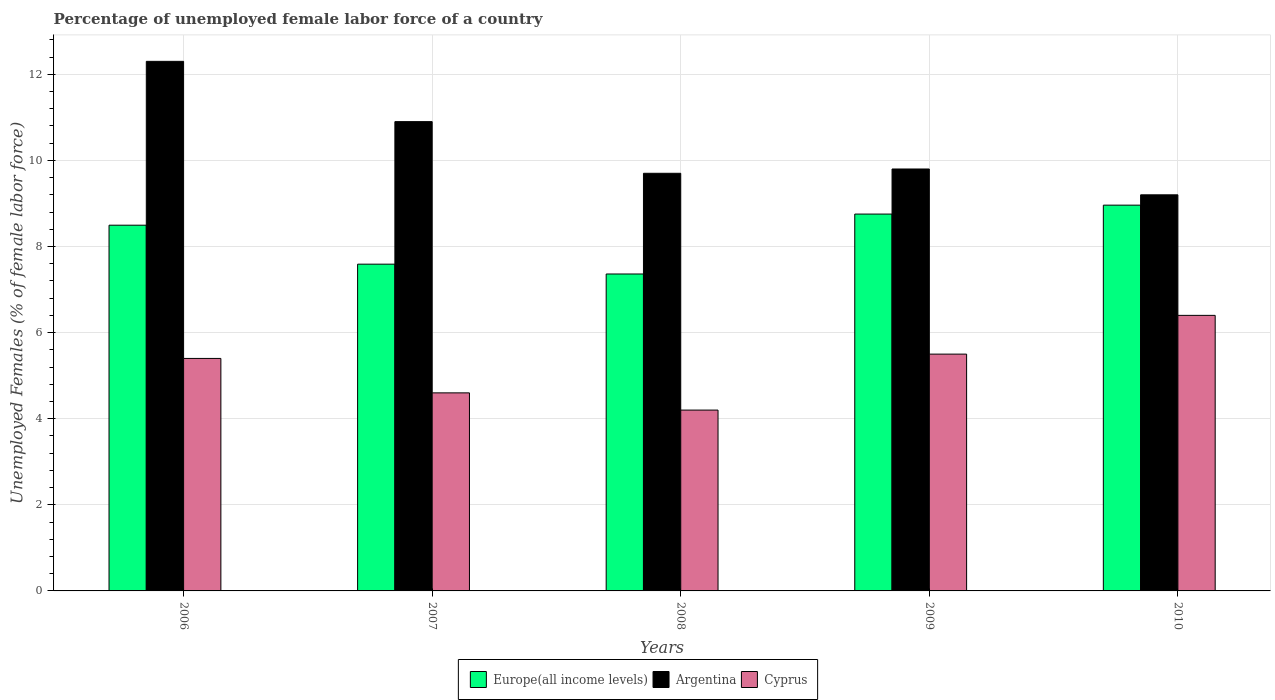How many different coloured bars are there?
Your response must be concise. 3. How many bars are there on the 4th tick from the left?
Your response must be concise. 3. How many bars are there on the 3rd tick from the right?
Provide a succinct answer. 3. In how many cases, is the number of bars for a given year not equal to the number of legend labels?
Your answer should be very brief. 0. What is the percentage of unemployed female labor force in Cyprus in 2007?
Offer a terse response. 4.6. Across all years, what is the maximum percentage of unemployed female labor force in Cyprus?
Keep it short and to the point. 6.4. Across all years, what is the minimum percentage of unemployed female labor force in Cyprus?
Your response must be concise. 4.2. What is the total percentage of unemployed female labor force in Cyprus in the graph?
Offer a terse response. 26.1. What is the difference between the percentage of unemployed female labor force in Argentina in 2006 and that in 2009?
Offer a terse response. 2.5. What is the difference between the percentage of unemployed female labor force in Europe(all income levels) in 2009 and the percentage of unemployed female labor force in Argentina in 2006?
Your response must be concise. -3.55. What is the average percentage of unemployed female labor force in Europe(all income levels) per year?
Give a very brief answer. 8.23. In the year 2010, what is the difference between the percentage of unemployed female labor force in Cyprus and percentage of unemployed female labor force in Europe(all income levels)?
Provide a succinct answer. -2.56. What is the ratio of the percentage of unemployed female labor force in Cyprus in 2009 to that in 2010?
Give a very brief answer. 0.86. Is the percentage of unemployed female labor force in Argentina in 2006 less than that in 2010?
Ensure brevity in your answer.  No. Is the difference between the percentage of unemployed female labor force in Cyprus in 2009 and 2010 greater than the difference between the percentage of unemployed female labor force in Europe(all income levels) in 2009 and 2010?
Your answer should be compact. No. What is the difference between the highest and the second highest percentage of unemployed female labor force in Cyprus?
Your answer should be compact. 0.9. What is the difference between the highest and the lowest percentage of unemployed female labor force in Europe(all income levels)?
Provide a short and direct response. 1.6. Is the sum of the percentage of unemployed female labor force in Europe(all income levels) in 2008 and 2010 greater than the maximum percentage of unemployed female labor force in Argentina across all years?
Keep it short and to the point. Yes. What does the 1st bar from the left in 2009 represents?
Give a very brief answer. Europe(all income levels). What does the 1st bar from the right in 2007 represents?
Provide a short and direct response. Cyprus. Is it the case that in every year, the sum of the percentage of unemployed female labor force in Cyprus and percentage of unemployed female labor force in Argentina is greater than the percentage of unemployed female labor force in Europe(all income levels)?
Make the answer very short. Yes. How many bars are there?
Make the answer very short. 15. How many years are there in the graph?
Provide a succinct answer. 5. Does the graph contain any zero values?
Give a very brief answer. No. Does the graph contain grids?
Provide a short and direct response. Yes. Where does the legend appear in the graph?
Provide a short and direct response. Bottom center. How many legend labels are there?
Provide a short and direct response. 3. How are the legend labels stacked?
Offer a very short reply. Horizontal. What is the title of the graph?
Offer a terse response. Percentage of unemployed female labor force of a country. What is the label or title of the Y-axis?
Make the answer very short. Unemployed Females (% of female labor force). What is the Unemployed Females (% of female labor force) of Europe(all income levels) in 2006?
Offer a terse response. 8.49. What is the Unemployed Females (% of female labor force) in Argentina in 2006?
Offer a terse response. 12.3. What is the Unemployed Females (% of female labor force) in Cyprus in 2006?
Provide a short and direct response. 5.4. What is the Unemployed Females (% of female labor force) of Europe(all income levels) in 2007?
Your answer should be compact. 7.59. What is the Unemployed Females (% of female labor force) in Argentina in 2007?
Provide a short and direct response. 10.9. What is the Unemployed Females (% of female labor force) in Cyprus in 2007?
Give a very brief answer. 4.6. What is the Unemployed Females (% of female labor force) of Europe(all income levels) in 2008?
Provide a short and direct response. 7.36. What is the Unemployed Females (% of female labor force) in Argentina in 2008?
Ensure brevity in your answer.  9.7. What is the Unemployed Females (% of female labor force) in Cyprus in 2008?
Keep it short and to the point. 4.2. What is the Unemployed Females (% of female labor force) of Europe(all income levels) in 2009?
Offer a terse response. 8.75. What is the Unemployed Females (% of female labor force) in Argentina in 2009?
Your answer should be compact. 9.8. What is the Unemployed Females (% of female labor force) in Europe(all income levels) in 2010?
Provide a short and direct response. 8.96. What is the Unemployed Females (% of female labor force) of Argentina in 2010?
Your answer should be compact. 9.2. What is the Unemployed Females (% of female labor force) in Cyprus in 2010?
Your response must be concise. 6.4. Across all years, what is the maximum Unemployed Females (% of female labor force) in Europe(all income levels)?
Provide a short and direct response. 8.96. Across all years, what is the maximum Unemployed Females (% of female labor force) in Argentina?
Give a very brief answer. 12.3. Across all years, what is the maximum Unemployed Females (% of female labor force) of Cyprus?
Provide a succinct answer. 6.4. Across all years, what is the minimum Unemployed Females (% of female labor force) of Europe(all income levels)?
Provide a short and direct response. 7.36. Across all years, what is the minimum Unemployed Females (% of female labor force) in Argentina?
Make the answer very short. 9.2. Across all years, what is the minimum Unemployed Females (% of female labor force) of Cyprus?
Your answer should be very brief. 4.2. What is the total Unemployed Females (% of female labor force) in Europe(all income levels) in the graph?
Offer a very short reply. 41.16. What is the total Unemployed Females (% of female labor force) of Argentina in the graph?
Provide a short and direct response. 51.9. What is the total Unemployed Females (% of female labor force) in Cyprus in the graph?
Offer a very short reply. 26.1. What is the difference between the Unemployed Females (% of female labor force) of Europe(all income levels) in 2006 and that in 2007?
Offer a terse response. 0.91. What is the difference between the Unemployed Females (% of female labor force) of Argentina in 2006 and that in 2007?
Your answer should be compact. 1.4. What is the difference between the Unemployed Females (% of female labor force) in Europe(all income levels) in 2006 and that in 2008?
Provide a succinct answer. 1.13. What is the difference between the Unemployed Females (% of female labor force) in Argentina in 2006 and that in 2008?
Ensure brevity in your answer.  2.6. What is the difference between the Unemployed Females (% of female labor force) in Cyprus in 2006 and that in 2008?
Your answer should be compact. 1.2. What is the difference between the Unemployed Females (% of female labor force) of Europe(all income levels) in 2006 and that in 2009?
Your answer should be very brief. -0.26. What is the difference between the Unemployed Females (% of female labor force) in Argentina in 2006 and that in 2009?
Make the answer very short. 2.5. What is the difference between the Unemployed Females (% of female labor force) in Cyprus in 2006 and that in 2009?
Give a very brief answer. -0.1. What is the difference between the Unemployed Females (% of female labor force) of Europe(all income levels) in 2006 and that in 2010?
Keep it short and to the point. -0.47. What is the difference between the Unemployed Females (% of female labor force) in Argentina in 2006 and that in 2010?
Keep it short and to the point. 3.1. What is the difference between the Unemployed Females (% of female labor force) of Cyprus in 2006 and that in 2010?
Your answer should be compact. -1. What is the difference between the Unemployed Females (% of female labor force) of Europe(all income levels) in 2007 and that in 2008?
Your answer should be compact. 0.23. What is the difference between the Unemployed Females (% of female labor force) of Europe(all income levels) in 2007 and that in 2009?
Provide a short and direct response. -1.16. What is the difference between the Unemployed Females (% of female labor force) in Cyprus in 2007 and that in 2009?
Provide a short and direct response. -0.9. What is the difference between the Unemployed Females (% of female labor force) of Europe(all income levels) in 2007 and that in 2010?
Your response must be concise. -1.37. What is the difference between the Unemployed Females (% of female labor force) of Cyprus in 2007 and that in 2010?
Your response must be concise. -1.8. What is the difference between the Unemployed Females (% of female labor force) of Europe(all income levels) in 2008 and that in 2009?
Make the answer very short. -1.39. What is the difference between the Unemployed Females (% of female labor force) of Cyprus in 2008 and that in 2009?
Provide a short and direct response. -1.3. What is the difference between the Unemployed Females (% of female labor force) of Europe(all income levels) in 2008 and that in 2010?
Make the answer very short. -1.6. What is the difference between the Unemployed Females (% of female labor force) in Cyprus in 2008 and that in 2010?
Keep it short and to the point. -2.2. What is the difference between the Unemployed Females (% of female labor force) in Europe(all income levels) in 2009 and that in 2010?
Make the answer very short. -0.21. What is the difference between the Unemployed Females (% of female labor force) in Cyprus in 2009 and that in 2010?
Offer a terse response. -0.9. What is the difference between the Unemployed Females (% of female labor force) of Europe(all income levels) in 2006 and the Unemployed Females (% of female labor force) of Argentina in 2007?
Ensure brevity in your answer.  -2.41. What is the difference between the Unemployed Females (% of female labor force) in Europe(all income levels) in 2006 and the Unemployed Females (% of female labor force) in Cyprus in 2007?
Your response must be concise. 3.89. What is the difference between the Unemployed Females (% of female labor force) of Europe(all income levels) in 2006 and the Unemployed Females (% of female labor force) of Argentina in 2008?
Ensure brevity in your answer.  -1.21. What is the difference between the Unemployed Females (% of female labor force) of Europe(all income levels) in 2006 and the Unemployed Females (% of female labor force) of Cyprus in 2008?
Give a very brief answer. 4.29. What is the difference between the Unemployed Females (% of female labor force) in Argentina in 2006 and the Unemployed Females (% of female labor force) in Cyprus in 2008?
Ensure brevity in your answer.  8.1. What is the difference between the Unemployed Females (% of female labor force) of Europe(all income levels) in 2006 and the Unemployed Females (% of female labor force) of Argentina in 2009?
Your answer should be very brief. -1.31. What is the difference between the Unemployed Females (% of female labor force) of Europe(all income levels) in 2006 and the Unemployed Females (% of female labor force) of Cyprus in 2009?
Your answer should be compact. 2.99. What is the difference between the Unemployed Females (% of female labor force) in Argentina in 2006 and the Unemployed Females (% of female labor force) in Cyprus in 2009?
Ensure brevity in your answer.  6.8. What is the difference between the Unemployed Females (% of female labor force) of Europe(all income levels) in 2006 and the Unemployed Females (% of female labor force) of Argentina in 2010?
Ensure brevity in your answer.  -0.71. What is the difference between the Unemployed Females (% of female labor force) of Europe(all income levels) in 2006 and the Unemployed Females (% of female labor force) of Cyprus in 2010?
Offer a terse response. 2.09. What is the difference between the Unemployed Females (% of female labor force) of Argentina in 2006 and the Unemployed Females (% of female labor force) of Cyprus in 2010?
Provide a succinct answer. 5.9. What is the difference between the Unemployed Females (% of female labor force) of Europe(all income levels) in 2007 and the Unemployed Females (% of female labor force) of Argentina in 2008?
Provide a succinct answer. -2.11. What is the difference between the Unemployed Females (% of female labor force) in Europe(all income levels) in 2007 and the Unemployed Females (% of female labor force) in Cyprus in 2008?
Your response must be concise. 3.39. What is the difference between the Unemployed Females (% of female labor force) in Argentina in 2007 and the Unemployed Females (% of female labor force) in Cyprus in 2008?
Offer a terse response. 6.7. What is the difference between the Unemployed Females (% of female labor force) of Europe(all income levels) in 2007 and the Unemployed Females (% of female labor force) of Argentina in 2009?
Your answer should be compact. -2.21. What is the difference between the Unemployed Females (% of female labor force) of Europe(all income levels) in 2007 and the Unemployed Females (% of female labor force) of Cyprus in 2009?
Your answer should be compact. 2.09. What is the difference between the Unemployed Females (% of female labor force) in Europe(all income levels) in 2007 and the Unemployed Females (% of female labor force) in Argentina in 2010?
Give a very brief answer. -1.61. What is the difference between the Unemployed Females (% of female labor force) in Europe(all income levels) in 2007 and the Unemployed Females (% of female labor force) in Cyprus in 2010?
Your answer should be compact. 1.19. What is the difference between the Unemployed Females (% of female labor force) of Europe(all income levels) in 2008 and the Unemployed Females (% of female labor force) of Argentina in 2009?
Ensure brevity in your answer.  -2.44. What is the difference between the Unemployed Females (% of female labor force) in Europe(all income levels) in 2008 and the Unemployed Females (% of female labor force) in Cyprus in 2009?
Offer a terse response. 1.86. What is the difference between the Unemployed Females (% of female labor force) of Europe(all income levels) in 2008 and the Unemployed Females (% of female labor force) of Argentina in 2010?
Make the answer very short. -1.84. What is the difference between the Unemployed Females (% of female labor force) in Europe(all income levels) in 2008 and the Unemployed Females (% of female labor force) in Cyprus in 2010?
Your answer should be compact. 0.96. What is the difference between the Unemployed Females (% of female labor force) in Argentina in 2008 and the Unemployed Females (% of female labor force) in Cyprus in 2010?
Offer a terse response. 3.3. What is the difference between the Unemployed Females (% of female labor force) of Europe(all income levels) in 2009 and the Unemployed Females (% of female labor force) of Argentina in 2010?
Provide a succinct answer. -0.45. What is the difference between the Unemployed Females (% of female labor force) in Europe(all income levels) in 2009 and the Unemployed Females (% of female labor force) in Cyprus in 2010?
Give a very brief answer. 2.35. What is the average Unemployed Females (% of female labor force) in Europe(all income levels) per year?
Offer a terse response. 8.23. What is the average Unemployed Females (% of female labor force) in Argentina per year?
Ensure brevity in your answer.  10.38. What is the average Unemployed Females (% of female labor force) of Cyprus per year?
Keep it short and to the point. 5.22. In the year 2006, what is the difference between the Unemployed Females (% of female labor force) in Europe(all income levels) and Unemployed Females (% of female labor force) in Argentina?
Your answer should be compact. -3.81. In the year 2006, what is the difference between the Unemployed Females (% of female labor force) of Europe(all income levels) and Unemployed Females (% of female labor force) of Cyprus?
Ensure brevity in your answer.  3.09. In the year 2006, what is the difference between the Unemployed Females (% of female labor force) in Argentina and Unemployed Females (% of female labor force) in Cyprus?
Give a very brief answer. 6.9. In the year 2007, what is the difference between the Unemployed Females (% of female labor force) in Europe(all income levels) and Unemployed Females (% of female labor force) in Argentina?
Make the answer very short. -3.31. In the year 2007, what is the difference between the Unemployed Females (% of female labor force) in Europe(all income levels) and Unemployed Females (% of female labor force) in Cyprus?
Ensure brevity in your answer.  2.99. In the year 2008, what is the difference between the Unemployed Females (% of female labor force) of Europe(all income levels) and Unemployed Females (% of female labor force) of Argentina?
Keep it short and to the point. -2.34. In the year 2008, what is the difference between the Unemployed Females (% of female labor force) in Europe(all income levels) and Unemployed Females (% of female labor force) in Cyprus?
Provide a succinct answer. 3.16. In the year 2009, what is the difference between the Unemployed Females (% of female labor force) in Europe(all income levels) and Unemployed Females (% of female labor force) in Argentina?
Your response must be concise. -1.05. In the year 2009, what is the difference between the Unemployed Females (% of female labor force) in Europe(all income levels) and Unemployed Females (% of female labor force) in Cyprus?
Ensure brevity in your answer.  3.25. In the year 2010, what is the difference between the Unemployed Females (% of female labor force) of Europe(all income levels) and Unemployed Females (% of female labor force) of Argentina?
Offer a terse response. -0.24. In the year 2010, what is the difference between the Unemployed Females (% of female labor force) in Europe(all income levels) and Unemployed Females (% of female labor force) in Cyprus?
Provide a short and direct response. 2.56. In the year 2010, what is the difference between the Unemployed Females (% of female labor force) in Argentina and Unemployed Females (% of female labor force) in Cyprus?
Keep it short and to the point. 2.8. What is the ratio of the Unemployed Females (% of female labor force) of Europe(all income levels) in 2006 to that in 2007?
Offer a very short reply. 1.12. What is the ratio of the Unemployed Females (% of female labor force) in Argentina in 2006 to that in 2007?
Keep it short and to the point. 1.13. What is the ratio of the Unemployed Females (% of female labor force) of Cyprus in 2006 to that in 2007?
Provide a short and direct response. 1.17. What is the ratio of the Unemployed Females (% of female labor force) in Europe(all income levels) in 2006 to that in 2008?
Provide a short and direct response. 1.15. What is the ratio of the Unemployed Females (% of female labor force) in Argentina in 2006 to that in 2008?
Keep it short and to the point. 1.27. What is the ratio of the Unemployed Females (% of female labor force) in Europe(all income levels) in 2006 to that in 2009?
Make the answer very short. 0.97. What is the ratio of the Unemployed Females (% of female labor force) of Argentina in 2006 to that in 2009?
Offer a very short reply. 1.26. What is the ratio of the Unemployed Females (% of female labor force) of Cyprus in 2006 to that in 2009?
Your answer should be very brief. 0.98. What is the ratio of the Unemployed Females (% of female labor force) in Europe(all income levels) in 2006 to that in 2010?
Provide a succinct answer. 0.95. What is the ratio of the Unemployed Females (% of female labor force) of Argentina in 2006 to that in 2010?
Make the answer very short. 1.34. What is the ratio of the Unemployed Females (% of female labor force) in Cyprus in 2006 to that in 2010?
Provide a succinct answer. 0.84. What is the ratio of the Unemployed Females (% of female labor force) in Europe(all income levels) in 2007 to that in 2008?
Offer a terse response. 1.03. What is the ratio of the Unemployed Females (% of female labor force) of Argentina in 2007 to that in 2008?
Your answer should be very brief. 1.12. What is the ratio of the Unemployed Females (% of female labor force) of Cyprus in 2007 to that in 2008?
Offer a terse response. 1.1. What is the ratio of the Unemployed Females (% of female labor force) in Europe(all income levels) in 2007 to that in 2009?
Your answer should be very brief. 0.87. What is the ratio of the Unemployed Females (% of female labor force) in Argentina in 2007 to that in 2009?
Ensure brevity in your answer.  1.11. What is the ratio of the Unemployed Females (% of female labor force) of Cyprus in 2007 to that in 2009?
Offer a terse response. 0.84. What is the ratio of the Unemployed Females (% of female labor force) in Europe(all income levels) in 2007 to that in 2010?
Your answer should be very brief. 0.85. What is the ratio of the Unemployed Females (% of female labor force) in Argentina in 2007 to that in 2010?
Your answer should be compact. 1.18. What is the ratio of the Unemployed Females (% of female labor force) in Cyprus in 2007 to that in 2010?
Offer a terse response. 0.72. What is the ratio of the Unemployed Females (% of female labor force) in Europe(all income levels) in 2008 to that in 2009?
Give a very brief answer. 0.84. What is the ratio of the Unemployed Females (% of female labor force) in Cyprus in 2008 to that in 2009?
Your answer should be compact. 0.76. What is the ratio of the Unemployed Females (% of female labor force) in Europe(all income levels) in 2008 to that in 2010?
Provide a succinct answer. 0.82. What is the ratio of the Unemployed Females (% of female labor force) in Argentina in 2008 to that in 2010?
Your response must be concise. 1.05. What is the ratio of the Unemployed Females (% of female labor force) of Cyprus in 2008 to that in 2010?
Give a very brief answer. 0.66. What is the ratio of the Unemployed Females (% of female labor force) of Europe(all income levels) in 2009 to that in 2010?
Ensure brevity in your answer.  0.98. What is the ratio of the Unemployed Females (% of female labor force) of Argentina in 2009 to that in 2010?
Keep it short and to the point. 1.07. What is the ratio of the Unemployed Females (% of female labor force) in Cyprus in 2009 to that in 2010?
Your answer should be compact. 0.86. What is the difference between the highest and the second highest Unemployed Females (% of female labor force) in Europe(all income levels)?
Provide a short and direct response. 0.21. What is the difference between the highest and the second highest Unemployed Females (% of female labor force) in Argentina?
Offer a very short reply. 1.4. What is the difference between the highest and the lowest Unemployed Females (% of female labor force) in Europe(all income levels)?
Offer a very short reply. 1.6. What is the difference between the highest and the lowest Unemployed Females (% of female labor force) of Cyprus?
Offer a very short reply. 2.2. 